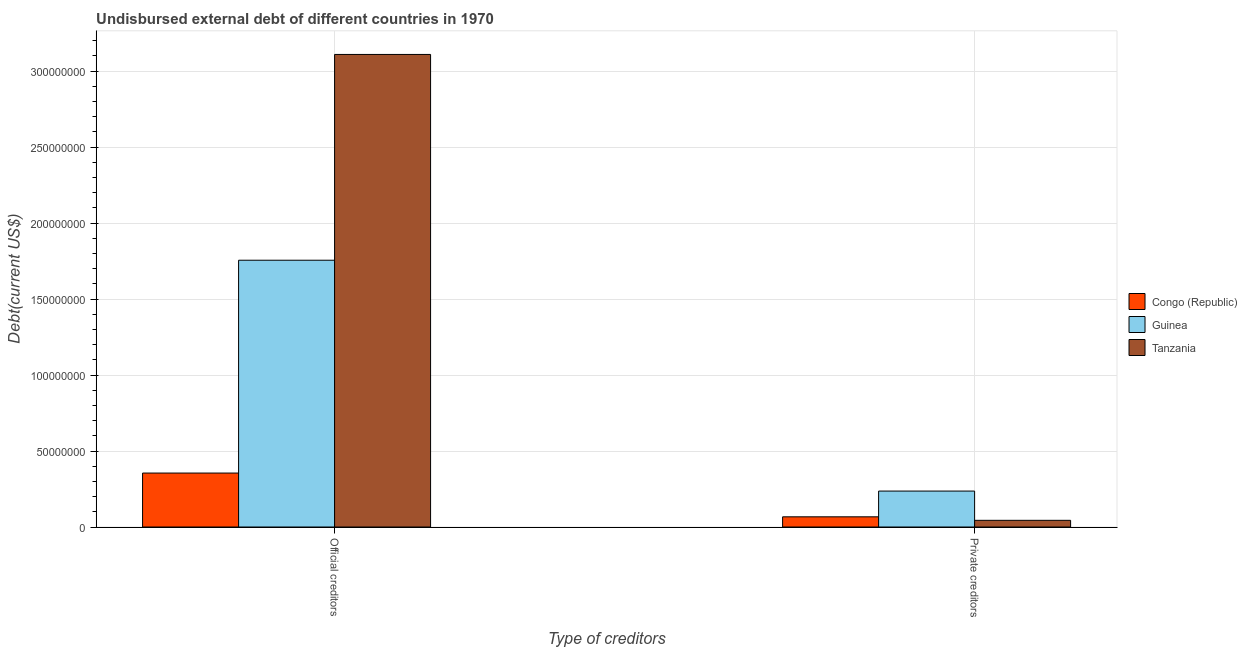How many different coloured bars are there?
Provide a short and direct response. 3. Are the number of bars per tick equal to the number of legend labels?
Provide a short and direct response. Yes. What is the label of the 2nd group of bars from the left?
Your response must be concise. Private creditors. What is the undisbursed external debt of official creditors in Congo (Republic)?
Offer a terse response. 3.55e+07. Across all countries, what is the maximum undisbursed external debt of official creditors?
Your answer should be very brief. 3.11e+08. Across all countries, what is the minimum undisbursed external debt of official creditors?
Ensure brevity in your answer.  3.55e+07. In which country was the undisbursed external debt of private creditors maximum?
Your answer should be compact. Guinea. In which country was the undisbursed external debt of private creditors minimum?
Offer a very short reply. Tanzania. What is the total undisbursed external debt of private creditors in the graph?
Provide a short and direct response. 3.48e+07. What is the difference between the undisbursed external debt of private creditors in Congo (Republic) and that in Tanzania?
Ensure brevity in your answer.  2.31e+06. What is the difference between the undisbursed external debt of official creditors in Guinea and the undisbursed external debt of private creditors in Congo (Republic)?
Keep it short and to the point. 1.69e+08. What is the average undisbursed external debt of official creditors per country?
Provide a succinct answer. 1.74e+08. What is the difference between the undisbursed external debt of private creditors and undisbursed external debt of official creditors in Congo (Republic)?
Give a very brief answer. -2.88e+07. What is the ratio of the undisbursed external debt of official creditors in Guinea to that in Tanzania?
Give a very brief answer. 0.56. Is the undisbursed external debt of private creditors in Congo (Republic) less than that in Tanzania?
Your response must be concise. No. What does the 3rd bar from the left in Private creditors represents?
Offer a very short reply. Tanzania. What does the 3rd bar from the right in Private creditors represents?
Make the answer very short. Congo (Republic). How many countries are there in the graph?
Offer a very short reply. 3. Does the graph contain any zero values?
Provide a short and direct response. No. Does the graph contain grids?
Provide a short and direct response. Yes. How many legend labels are there?
Keep it short and to the point. 3. How are the legend labels stacked?
Your answer should be compact. Vertical. What is the title of the graph?
Your answer should be very brief. Undisbursed external debt of different countries in 1970. Does "Chile" appear as one of the legend labels in the graph?
Keep it short and to the point. No. What is the label or title of the X-axis?
Your response must be concise. Type of creditors. What is the label or title of the Y-axis?
Offer a very short reply. Debt(current US$). What is the Debt(current US$) in Congo (Republic) in Official creditors?
Your response must be concise. 3.55e+07. What is the Debt(current US$) of Guinea in Official creditors?
Give a very brief answer. 1.76e+08. What is the Debt(current US$) in Tanzania in Official creditors?
Offer a terse response. 3.11e+08. What is the Debt(current US$) in Congo (Republic) in Private creditors?
Ensure brevity in your answer.  6.71e+06. What is the Debt(current US$) of Guinea in Private creditors?
Give a very brief answer. 2.36e+07. What is the Debt(current US$) of Tanzania in Private creditors?
Your response must be concise. 4.40e+06. Across all Type of creditors, what is the maximum Debt(current US$) of Congo (Republic)?
Ensure brevity in your answer.  3.55e+07. Across all Type of creditors, what is the maximum Debt(current US$) of Guinea?
Make the answer very short. 1.76e+08. Across all Type of creditors, what is the maximum Debt(current US$) of Tanzania?
Give a very brief answer. 3.11e+08. Across all Type of creditors, what is the minimum Debt(current US$) of Congo (Republic)?
Provide a short and direct response. 6.71e+06. Across all Type of creditors, what is the minimum Debt(current US$) of Guinea?
Make the answer very short. 2.36e+07. Across all Type of creditors, what is the minimum Debt(current US$) in Tanzania?
Offer a terse response. 4.40e+06. What is the total Debt(current US$) of Congo (Republic) in the graph?
Keep it short and to the point. 4.22e+07. What is the total Debt(current US$) in Guinea in the graph?
Provide a short and direct response. 1.99e+08. What is the total Debt(current US$) of Tanzania in the graph?
Offer a terse response. 3.15e+08. What is the difference between the Debt(current US$) in Congo (Republic) in Official creditors and that in Private creditors?
Give a very brief answer. 2.88e+07. What is the difference between the Debt(current US$) of Guinea in Official creditors and that in Private creditors?
Keep it short and to the point. 1.52e+08. What is the difference between the Debt(current US$) in Tanzania in Official creditors and that in Private creditors?
Offer a very short reply. 3.06e+08. What is the difference between the Debt(current US$) in Congo (Republic) in Official creditors and the Debt(current US$) in Guinea in Private creditors?
Ensure brevity in your answer.  1.18e+07. What is the difference between the Debt(current US$) of Congo (Republic) in Official creditors and the Debt(current US$) of Tanzania in Private creditors?
Provide a succinct answer. 3.11e+07. What is the difference between the Debt(current US$) in Guinea in Official creditors and the Debt(current US$) in Tanzania in Private creditors?
Provide a short and direct response. 1.71e+08. What is the average Debt(current US$) of Congo (Republic) per Type of creditors?
Your answer should be very brief. 2.11e+07. What is the average Debt(current US$) of Guinea per Type of creditors?
Offer a terse response. 9.96e+07. What is the average Debt(current US$) in Tanzania per Type of creditors?
Ensure brevity in your answer.  1.58e+08. What is the difference between the Debt(current US$) in Congo (Republic) and Debt(current US$) in Guinea in Official creditors?
Offer a very short reply. -1.40e+08. What is the difference between the Debt(current US$) in Congo (Republic) and Debt(current US$) in Tanzania in Official creditors?
Make the answer very short. -2.75e+08. What is the difference between the Debt(current US$) of Guinea and Debt(current US$) of Tanzania in Official creditors?
Your answer should be very brief. -1.35e+08. What is the difference between the Debt(current US$) of Congo (Republic) and Debt(current US$) of Guinea in Private creditors?
Provide a succinct answer. -1.69e+07. What is the difference between the Debt(current US$) of Congo (Republic) and Debt(current US$) of Tanzania in Private creditors?
Keep it short and to the point. 2.31e+06. What is the difference between the Debt(current US$) in Guinea and Debt(current US$) in Tanzania in Private creditors?
Your answer should be compact. 1.92e+07. What is the ratio of the Debt(current US$) of Congo (Republic) in Official creditors to that in Private creditors?
Keep it short and to the point. 5.29. What is the ratio of the Debt(current US$) of Guinea in Official creditors to that in Private creditors?
Your response must be concise. 7.42. What is the ratio of the Debt(current US$) in Tanzania in Official creditors to that in Private creditors?
Offer a very short reply. 70.66. What is the difference between the highest and the second highest Debt(current US$) of Congo (Republic)?
Provide a short and direct response. 2.88e+07. What is the difference between the highest and the second highest Debt(current US$) of Guinea?
Ensure brevity in your answer.  1.52e+08. What is the difference between the highest and the second highest Debt(current US$) of Tanzania?
Ensure brevity in your answer.  3.06e+08. What is the difference between the highest and the lowest Debt(current US$) of Congo (Republic)?
Offer a very short reply. 2.88e+07. What is the difference between the highest and the lowest Debt(current US$) in Guinea?
Give a very brief answer. 1.52e+08. What is the difference between the highest and the lowest Debt(current US$) of Tanzania?
Offer a terse response. 3.06e+08. 